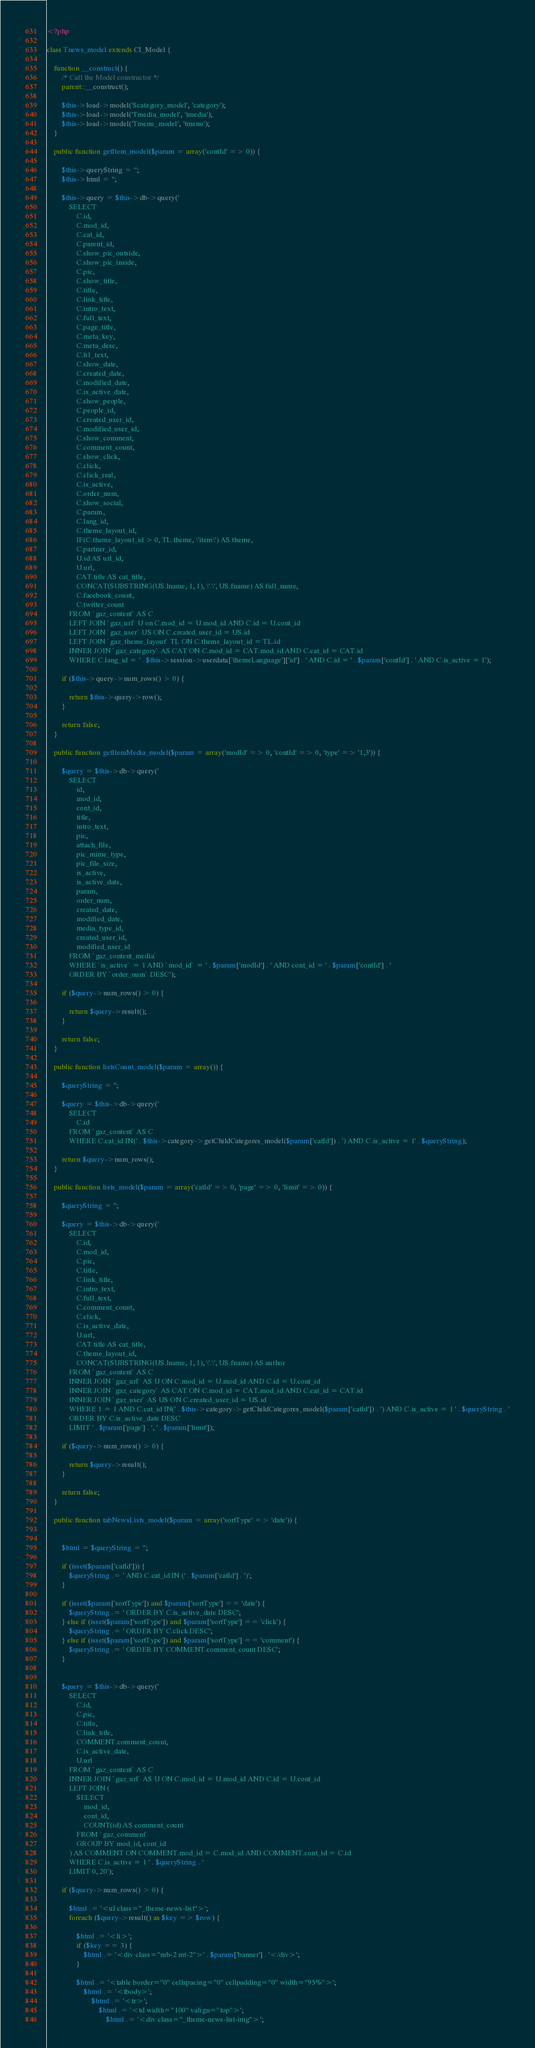<code> <loc_0><loc_0><loc_500><loc_500><_PHP_><?php

class Tnews_model extends CI_Model {

    function __construct() {
        /* Call the Model constructor */
        parent::__construct();

        $this->load->model('Scategory_model', 'category');
        $this->load->model('Tmedia_model', 'tmedia');
        $this->load->model('Tmenu_model', 'tmenu');
    }

    public function getItem_model($param = array('contId' => 0)) {

        $this->queryString = '';
        $this->html = '';

        $this->query = $this->db->query('
            SELECT 
                C.id,
                C.mod_id,
                C.cat_id,
                C.parent_id,
                C.show_pic_outside,
                C.show_pic_inside,
                C.pic,
                C.show_title,
                C.title,
                C.link_title,
                C.intro_text,
                C.full_text,
                C.page_title,
                C.meta_key,
                C.meta_desc,
                C.h1_text,
                C.show_date,
                C.created_date,
                C.modified_date,
                C.is_active_date,
                C.show_people,
                C.people_id,
                C.created_user_id,
                C.modified_user_id,
                C.show_comment,
                C.comment_count,
                C.show_click,
                C.click,
                C.click_real,
                C.is_active,
                C.order_num,
                C.show_social,
                C.param,
                C.lang_id,
                C.theme_layout_id,
                IF(C.theme_layout_id > 0, TL.theme, \'item\') AS theme,
                C.partner_id,
                U.id AS url_id,
                U.url,
                CAT.title AS cat_title,
                CONCAT(SUBSTRING(US.lname, 1, 1), \'.\', US.fname) AS full_name,
                C.facebook_count,
                C.twitter_count
            FROM `gaz_content` AS C
            LEFT JOIN `gaz_url` U on C.mod_id = U.mod_id AND C.id = U.cont_id 
            LEFT JOIN `gaz_user` US ON C.created_user_id = US.id
            LEFT JOIN `gaz_theme_layout` TL ON C.theme_layout_id = TL.id
            INNER JOIN `gaz_category` AS CAT ON C.mod_id = CAT.mod_id AND C.cat_id = CAT.id
            WHERE C.lang_id = ' . $this->session->userdata['themeLanguage']['id'] . ' AND C.id = ' . $param['contId'] . ' AND C.is_active = 1');

        if ($this->query->num_rows() > 0) {

            return $this->query->row();
        }

        return false;
    }

    public function getItemMedia_model($param = array('modId' => 0, 'contId' => 0, 'type' => '1,3')) {

        $query = $this->db->query('
            SELECT 
                id,
                mod_id,
                cont_id,
                title,
                intro_text,
                pic,
                attach_file,
                pic_mime_type,
                pic_file_size,
                is_active,
                is_active_date,
                param,
                order_num,
                created_date,
                modified_date,
                media_type_id,
                created_user_id,
                modified_user_id
            FROM `gaz_content_media` 
            WHERE `is_active` = 1 AND `mod_id` = ' . $param['modId'] . ' AND cont_id = ' . $param['contId'] . '
            ORDER BY `order_num` DESC');

        if ($query->num_rows() > 0) {

            return $query->result();
        }

        return false;
    }

    public function listsCount_model($param = array()) {

        $queryString = '';

        $query = $this->db->query('
            SELECT 
                C.id
            FROM `gaz_content` AS C
            WHERE C.cat_id IN(' . $this->category->getChildCategores_model($param['catId']) . ') AND C.is_active = 1' . $queryString);

        return $query->num_rows();
    }

    public function lists_model($param = array('catId' => 0, 'page' => 0, 'limit' => 0)) {

        $queryString = '';

        $query = $this->db->query('
            SELECT 
                C.id,
                C.mod_id,
                C.pic,
                C.title,
                C.link_title,
                C.intro_text,
                C.full_text,
                C.comment_count,
                C.click,
                C.is_active_date,
                U.url,
                CAT.title AS cat_title,
                C.theme_layout_id,
                CONCAT(SUBSTRING(US.lname, 1, 1), \'.\', US.fname) AS author
            FROM `gaz_content` AS C
            INNER JOIN `gaz_url` AS U ON C.mod_id = U.mod_id AND C.id = U.cont_id
            INNER JOIN `gaz_category` AS CAT ON C.mod_id = CAT.mod_id AND C.cat_id = CAT.id
            INNER JOIN `gaz_user` AS US ON C.created_user_id = US.id
            WHERE 1 = 1 AND C.cat_id IN(' . $this->category->getChildCategores_model($param['catId']) . ') AND C.is_active = 1 ' . $queryString . '
            ORDER BY C.is_active_date DESC
            LIMIT ' . $param['page'] . ', ' . $param['limit']);

        if ($query->num_rows() > 0) {

            return $query->result();
        }

        return false;
    }

    public function tabNewsLists_model($param = array('sortType' => 'date')) {


        $html = $queryString = '';

        if (isset($param['catId'])) {
            $queryString .= ' AND C.cat_id IN (' . $param['catId'] . ')';
        }

        if (isset($param['sortType']) and $param['sortType'] == 'date') {
            $queryString .= ' ORDER BY C.is_active_date DESC';
        } else if (isset($param['sortType']) and $param['sortType'] == 'click') {
            $queryString .= ' ORDER BY C.click DESC';
        } else if (isset($param['sortType']) and $param['sortType'] == 'comment') {
            $queryString .= ' ORDER BY COMMENT.comment_count DESC';
        }


        $query = $this->db->query('
            SELECT 
                C.id,
                C.pic,
                C.title,
                C.link_title,
                COMMENT.comment_count,
                C.is_active_date,
                U.url
            FROM `gaz_content` AS C
            INNER JOIN `gaz_url` AS U ON C.mod_id = U.mod_id AND C.id = U.cont_id
            LEFT JOIN (
                SELECT 
                    mod_id,
                    cont_id,
                    COUNT(id) AS comment_count
                FROM `gaz_comment`
                GROUP BY mod_id, cont_id
            ) AS COMMENT ON COMMENT.mod_id = C.mod_id AND COMMENT.cont_id = C.id
            WHERE C.is_active = 1 ' . $queryString . '
            LIMIT 0, 20');

        if ($query->num_rows() > 0) {

            $html .= '<ul class="_theme-news-list">';
            foreach ($query->result() as $key => $row) {

                $html .= '<li>';
                if ($key == 3) {
                    $html .= '<div class="mb-2 mt-2">' . $param['banner'] . '</div>';
                }
                
                $html .= '<table border="0" cellspacing="0" cellpadding="0" width="95%">';
                    $html .= '<tbody>';
                        $html .= '<tr>';
                            $html .= '<td width="100" valign="top">';
                                $html .= '<div class="_theme-news-list-img">';</code> 